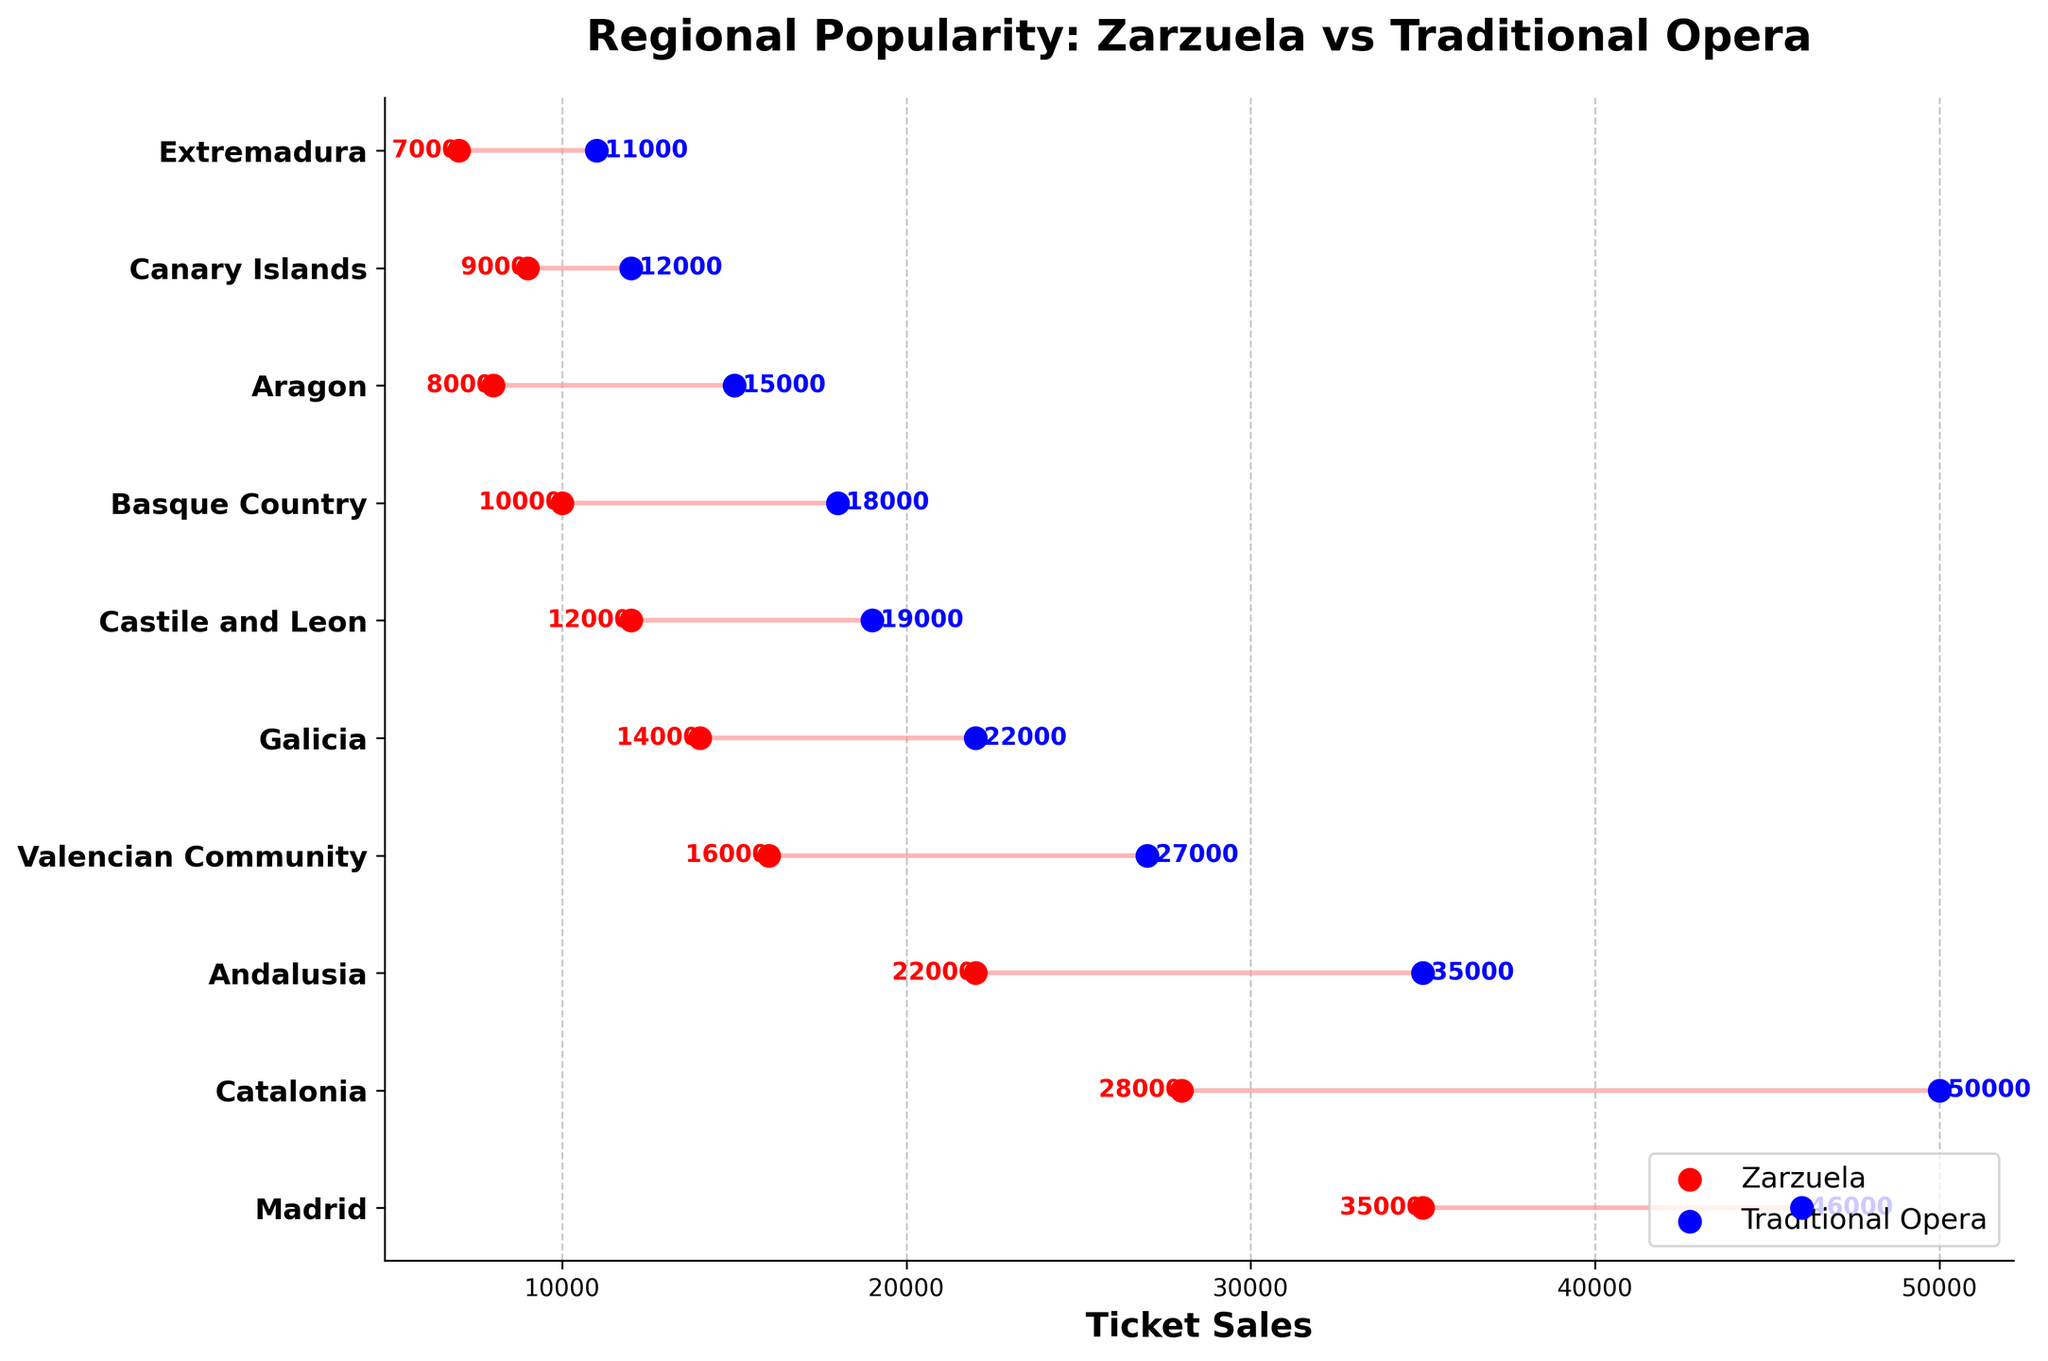What's the title of the figure? The title of the figure appears at the top center of the plot. It describes what the plot is about.
Answer: Regional Popularity: Zarzuela vs Traditional Opera Which region has the highest ticket sales for traditional opera? By looking at the blue dots and their respective labels, we can identify the region with the highest number of traditional opera ticket sales.
Answer: Catalonia What is the difference in ticket sales for zarzuela and traditional opera in the Basque Country? Find the number of ticket sales for both zarzuela (10,000) and traditional opera (18,000) in the Basque Country and then subtract the smaller value from the larger value (18,000 - 10,000).
Answer: 8,000 Which region shows the smallest gap between zarzuela and traditional opera ticket sales? Compare the difference between ticket sales for zarzuela and traditional opera across all regions. Look for the smallest difference. For example, for Canary Islands: 12,000 - 9,000 = 3,000, and proceed similarly for all other regions.
Answer: Canary Islands What are the ticket sales for zarzuela and traditional opera in Catalonia? Locate the labels for Catalonia and read the values next to the red and blue dots, respectively.
Answer: 28,000 (zarzuela), 50,000 (traditional opera) Which region has the highest ticket sales for zarzuela? By looking at the red dots and their respective labels, we can recognize the region with the highest number of zarzuela ticket sales.
Answer: Madrid What is the average ticket sales for traditional opera across all regions? Sum all the ticket sales for traditional opera and divide by the number of regions. (46000 + 50000 + 35000 + 27000 + 22000 + 19000 + 18000 + 15000 + 12000 + 11000 = 255,000; 255,000 / 10 regions).
Answer: 25,500 How many regions have over 20,000 ticket sales for zarzuela? Count the number of regions where the red dots (zarzuela ticket sales) are above the 20,000 mark.
Answer: 3 Which region has the largest difference in ticket sales between zarzuela and traditional opera? Compare the differences between the ticket sales for zarzuela and traditional opera across all regions. Identify the region with the largest difference. For example, for Catalonia: 50,000 - 28,000 = 22,000, and proceed similarly for all other regions.
Answer: Catalonia What do the red and blue colors represent in the plot? Check the legend at the bottom right corner of the plot. The red signifies zarzuela ticket sales, and the blue signifies traditional opera ticket sales.
Answer: Zarzuela (red), Traditional Opera (blue) 